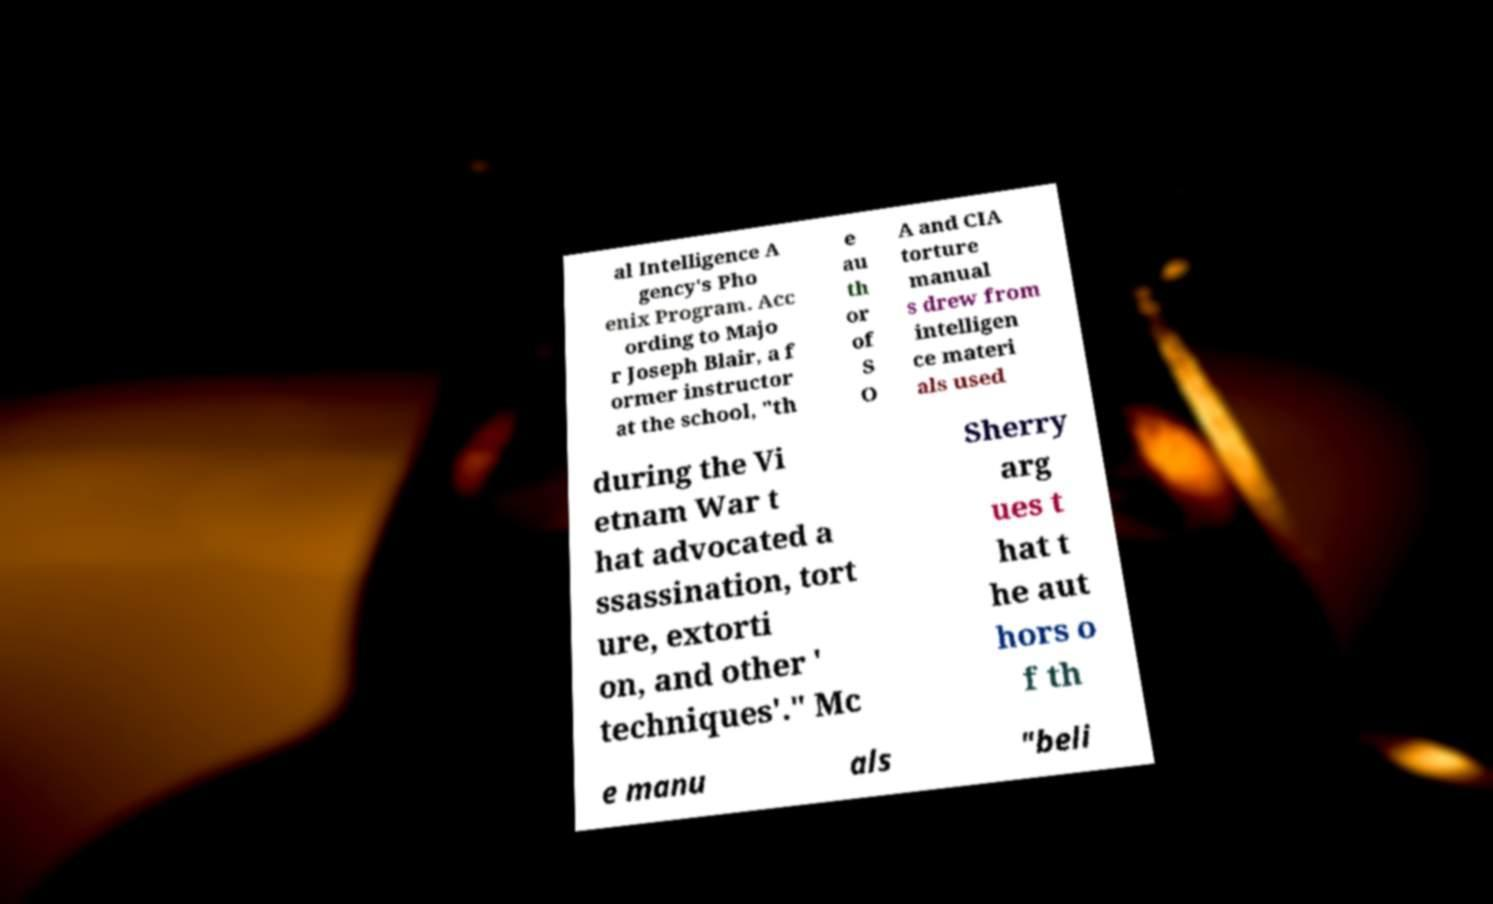Can you read and provide the text displayed in the image?This photo seems to have some interesting text. Can you extract and type it out for me? al Intelligence A gency's Pho enix Program. Acc ording to Majo r Joseph Blair, a f ormer instructor at the school, "th e au th or of S O A and CIA torture manual s drew from intelligen ce materi als used during the Vi etnam War t hat advocated a ssassination, tort ure, extorti on, and other ' techniques'." Mc Sherry arg ues t hat t he aut hors o f th e manu als "beli 